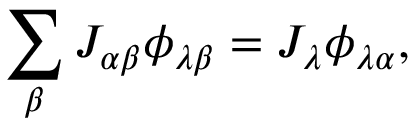<formula> <loc_0><loc_0><loc_500><loc_500>\sum _ { \beta } J _ { \alpha \beta } \phi _ { \lambda \beta } = J _ { \lambda } \phi _ { \lambda \alpha } ,</formula> 